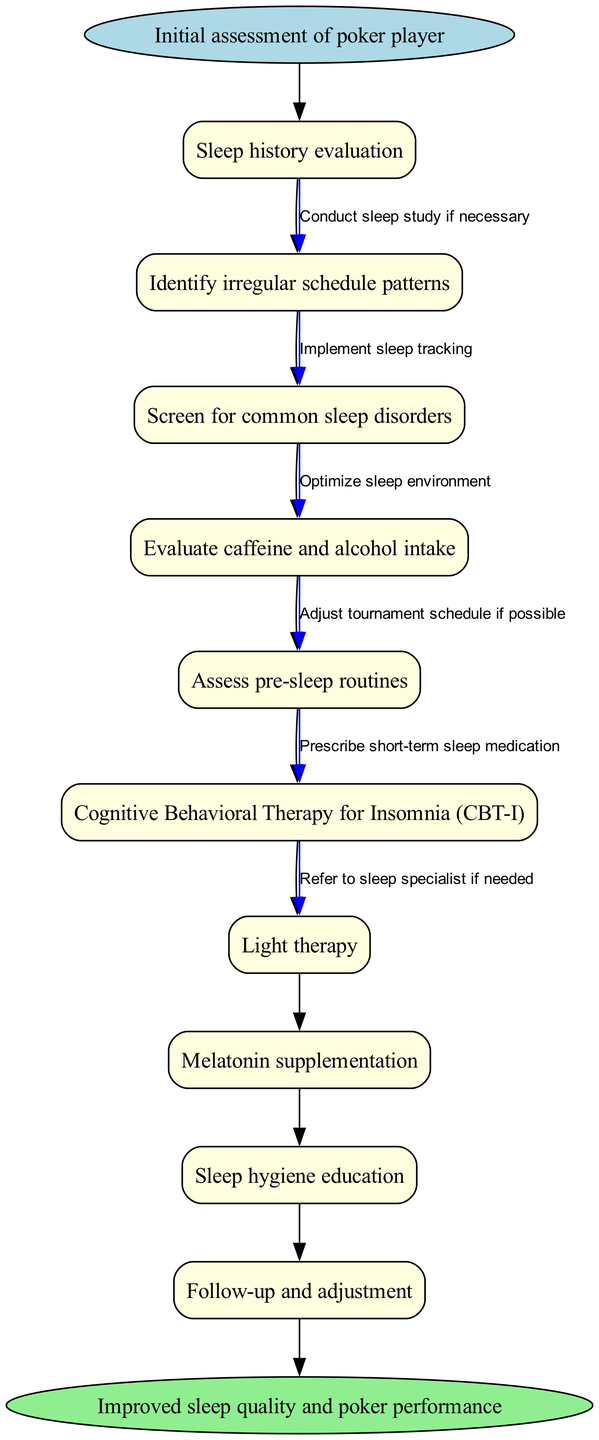What is the first step in the clinical pathway? The diagram starts with the "Initial assessment of poker player," which is the first node indicating where the pathway begins.
Answer: Initial assessment of poker player How many nodes are present in the clinical pathway? There are 10 nodes listed in the diagram, including the start and end nodes, along with the intermediate steps.
Answer: 10 What therapy is indicated for insomnia? "Cognitive Behavioral Therapy for Insomnia (CBT-I)" is one of the nodes dedicated specifically to addressing insomnia within the pathway.
Answer: Cognitive Behavioral Therapy for Insomnia (CBT-I) What should be evaluated to identify sleep disorders? The diagram suggests "Screen for common sleep disorders" as a step to evaluate and determine any sleep issues that may be present.
Answer: Screen for common sleep disorders How are caffeine and alcohol managed in this clinical pathway? "Evaluate caffeine and alcohol intake" is a crucial step in assessing factors that may contribute to sleep disorders in poker players.
Answer: Evaluate caffeine and alcohol intake What is the final outcome of the clinical pathway? The end node states "Improved sleep quality and poker performance" as the desired outcome of following the pathway.
Answer: Improved sleep quality and poker performance How does a poker player begin the evaluation process? The first edge connects the start node to "Sleep history evaluation," indicating that this is how the evaluation process initiates.
Answer: Sleep history evaluation Which node relates to adjusting sleep environment? The edge from the "Assess pre-sleep routines" node indicates "Optimize sleep environment," pointing to the necessity of creating a conducive sleeping area.
Answer: Optimize sleep environment What is a potential adjustment for the tournament schedule? "Adjust tournament schedule if possible" is mentioned as a potential change that could help improve a poker player’s sleep quality.
Answer: Adjust tournament schedule if possible 